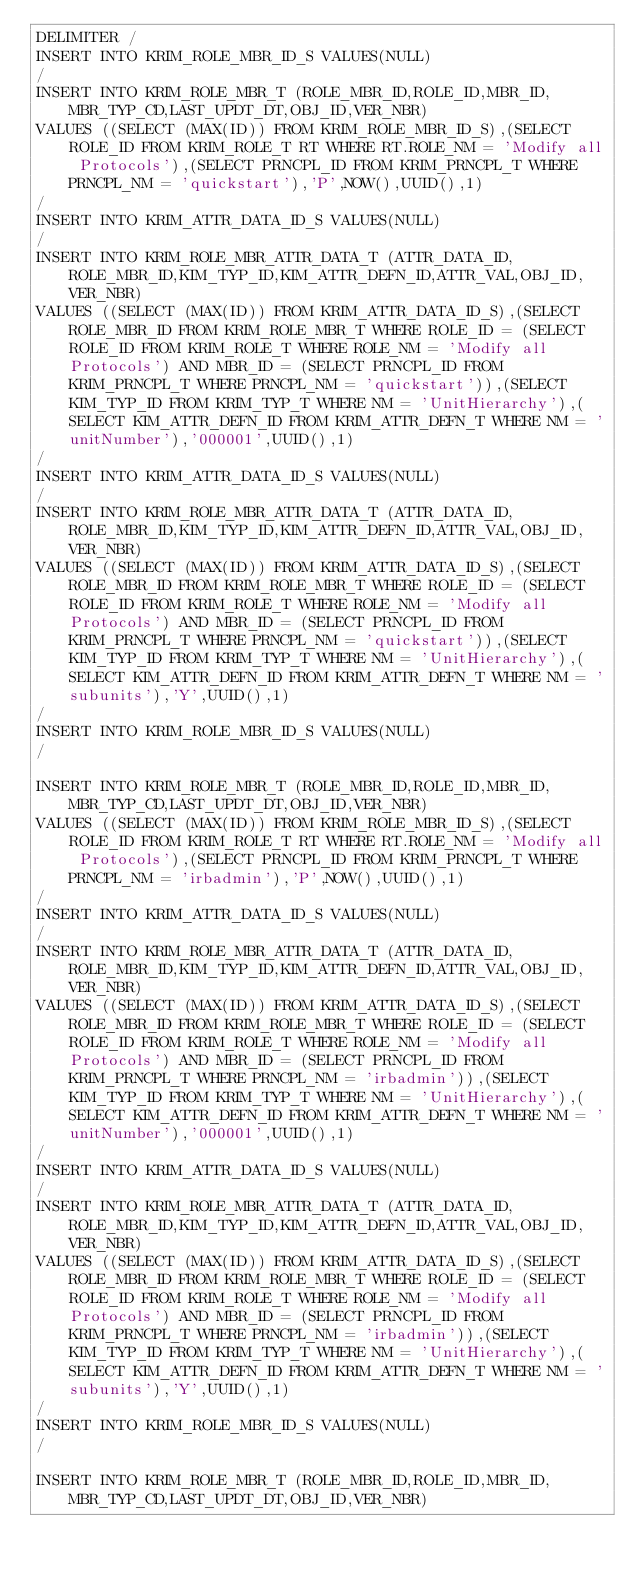Convert code to text. <code><loc_0><loc_0><loc_500><loc_500><_SQL_>DELIMITER /
INSERT INTO KRIM_ROLE_MBR_ID_S VALUES(NULL)
/
INSERT INTO KRIM_ROLE_MBR_T (ROLE_MBR_ID,ROLE_ID,MBR_ID,MBR_TYP_CD,LAST_UPDT_DT,OBJ_ID,VER_NBR) 
VALUES ((SELECT (MAX(ID)) FROM KRIM_ROLE_MBR_ID_S),(SELECT ROLE_ID FROM KRIM_ROLE_T RT WHERE RT.ROLE_NM = 'Modify all Protocols'),(SELECT PRNCPL_ID FROM KRIM_PRNCPL_T WHERE PRNCPL_NM = 'quickstart'),'P',NOW(),UUID(),1)
/
INSERT INTO KRIM_ATTR_DATA_ID_S VALUES(NULL)
/
INSERT INTO KRIM_ROLE_MBR_ATTR_DATA_T (ATTR_DATA_ID,ROLE_MBR_ID,KIM_TYP_ID,KIM_ATTR_DEFN_ID,ATTR_VAL,OBJ_ID,VER_NBR)
VALUES ((SELECT (MAX(ID)) FROM KRIM_ATTR_DATA_ID_S),(SELECT ROLE_MBR_ID FROM KRIM_ROLE_MBR_T WHERE ROLE_ID = (SELECT ROLE_ID FROM KRIM_ROLE_T WHERE ROLE_NM = 'Modify all Protocols') AND MBR_ID = (SELECT PRNCPL_ID FROM KRIM_PRNCPL_T WHERE PRNCPL_NM = 'quickstart')),(SELECT KIM_TYP_ID FROM KRIM_TYP_T WHERE NM = 'UnitHierarchy'),(SELECT KIM_ATTR_DEFN_ID FROM KRIM_ATTR_DEFN_T WHERE NM = 'unitNumber'),'000001',UUID(),1)
/
INSERT INTO KRIM_ATTR_DATA_ID_S VALUES(NULL)
/
INSERT INTO KRIM_ROLE_MBR_ATTR_DATA_T (ATTR_DATA_ID,ROLE_MBR_ID,KIM_TYP_ID,KIM_ATTR_DEFN_ID,ATTR_VAL,OBJ_ID,VER_NBR)
VALUES ((SELECT (MAX(ID)) FROM KRIM_ATTR_DATA_ID_S),(SELECT ROLE_MBR_ID FROM KRIM_ROLE_MBR_T WHERE ROLE_ID = (SELECT ROLE_ID FROM KRIM_ROLE_T WHERE ROLE_NM = 'Modify all Protocols') AND MBR_ID = (SELECT PRNCPL_ID FROM KRIM_PRNCPL_T WHERE PRNCPL_NM = 'quickstart')),(SELECT KIM_TYP_ID FROM KRIM_TYP_T WHERE NM = 'UnitHierarchy'),(SELECT KIM_ATTR_DEFN_ID FROM KRIM_ATTR_DEFN_T WHERE NM = 'subunits'),'Y',UUID(),1)
/
INSERT INTO KRIM_ROLE_MBR_ID_S VALUES(NULL)
/

INSERT INTO KRIM_ROLE_MBR_T (ROLE_MBR_ID,ROLE_ID,MBR_ID,MBR_TYP_CD,LAST_UPDT_DT,OBJ_ID,VER_NBR) 
VALUES ((SELECT (MAX(ID)) FROM KRIM_ROLE_MBR_ID_S),(SELECT ROLE_ID FROM KRIM_ROLE_T RT WHERE RT.ROLE_NM = 'Modify all Protocols'),(SELECT PRNCPL_ID FROM KRIM_PRNCPL_T WHERE PRNCPL_NM = 'irbadmin'),'P',NOW(),UUID(),1)
/
INSERT INTO KRIM_ATTR_DATA_ID_S VALUES(NULL)
/
INSERT INTO KRIM_ROLE_MBR_ATTR_DATA_T (ATTR_DATA_ID,ROLE_MBR_ID,KIM_TYP_ID,KIM_ATTR_DEFN_ID,ATTR_VAL,OBJ_ID,VER_NBR)
VALUES ((SELECT (MAX(ID)) FROM KRIM_ATTR_DATA_ID_S),(SELECT ROLE_MBR_ID FROM KRIM_ROLE_MBR_T WHERE ROLE_ID = (SELECT ROLE_ID FROM KRIM_ROLE_T WHERE ROLE_NM = 'Modify all Protocols') AND MBR_ID = (SELECT PRNCPL_ID FROM KRIM_PRNCPL_T WHERE PRNCPL_NM = 'irbadmin')),(SELECT KIM_TYP_ID FROM KRIM_TYP_T WHERE NM = 'UnitHierarchy'),(SELECT KIM_ATTR_DEFN_ID FROM KRIM_ATTR_DEFN_T WHERE NM = 'unitNumber'),'000001',UUID(),1)
/
INSERT INTO KRIM_ATTR_DATA_ID_S VALUES(NULL)
/
INSERT INTO KRIM_ROLE_MBR_ATTR_DATA_T (ATTR_DATA_ID,ROLE_MBR_ID,KIM_TYP_ID,KIM_ATTR_DEFN_ID,ATTR_VAL,OBJ_ID,VER_NBR)
VALUES ((SELECT (MAX(ID)) FROM KRIM_ATTR_DATA_ID_S),(SELECT ROLE_MBR_ID FROM KRIM_ROLE_MBR_T WHERE ROLE_ID = (SELECT ROLE_ID FROM KRIM_ROLE_T WHERE ROLE_NM = 'Modify all Protocols') AND MBR_ID = (SELECT PRNCPL_ID FROM KRIM_PRNCPL_T WHERE PRNCPL_NM = 'irbadmin')),(SELECT KIM_TYP_ID FROM KRIM_TYP_T WHERE NM = 'UnitHierarchy'),(SELECT KIM_ATTR_DEFN_ID FROM KRIM_ATTR_DEFN_T WHERE NM = 'subunits'),'Y',UUID(),1)
/
INSERT INTO KRIM_ROLE_MBR_ID_S VALUES(NULL)
/

INSERT INTO KRIM_ROLE_MBR_T (ROLE_MBR_ID,ROLE_ID,MBR_ID,MBR_TYP_CD,LAST_UPDT_DT,OBJ_ID,VER_NBR) </code> 